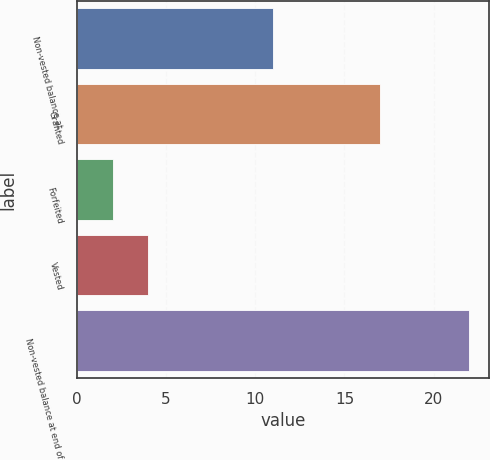Convert chart to OTSL. <chart><loc_0><loc_0><loc_500><loc_500><bar_chart><fcel>Non-vested balance at<fcel>Granted<fcel>Forfeited<fcel>Vested<fcel>Non-vested balance at end of<nl><fcel>11<fcel>17<fcel>2<fcel>4<fcel>22<nl></chart> 